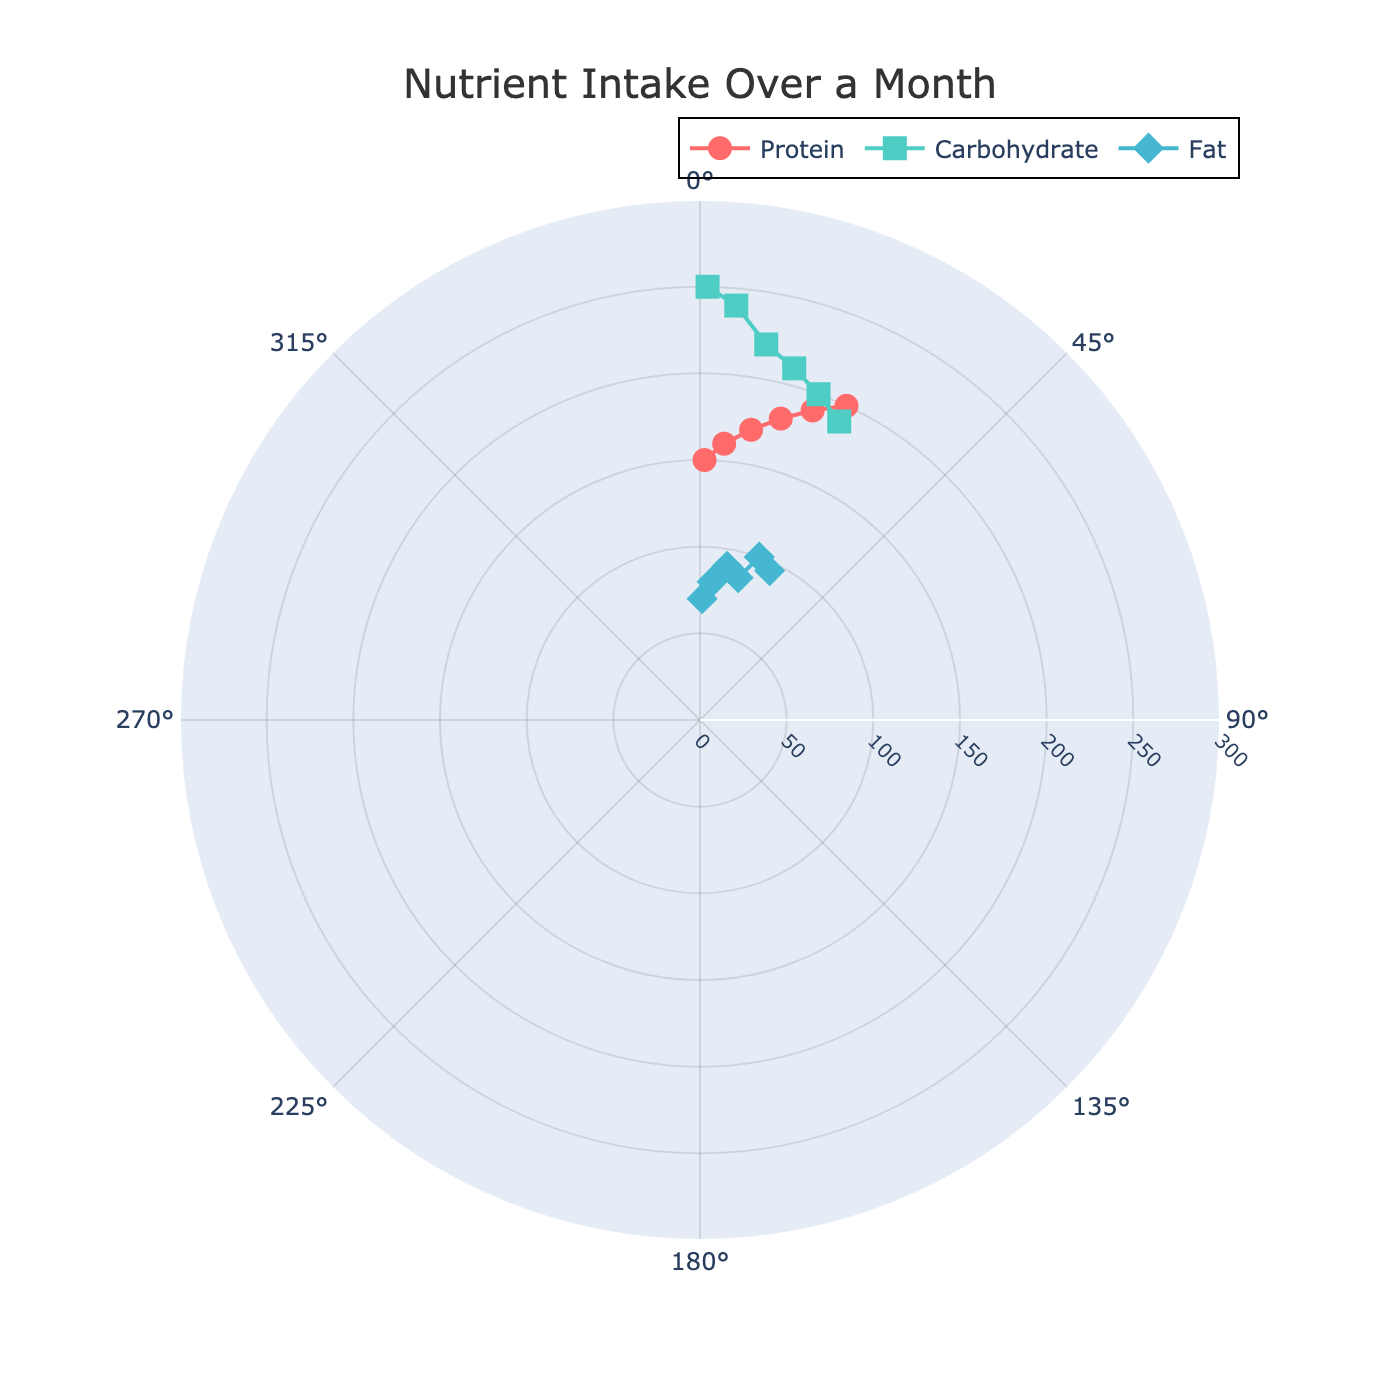How many data points are represented for each nutrient? The plot shows markers for each nutrient on multiple days. For each nutrient, there are data points on days 1, 5, 10, 15, 20, and 25. So, each nutrient has 6 data points.
Answer: 6 What days were protein intake measurements taken? Observing the plot, protein intake data points are found on days 1, 5, 10, 15, 20, and 25, as represented by the circular markers.
Answer: 1, 5, 10, 15, 20, 25 What is the intake of fat on day 10? The plot shows a diamond marker for fat data. Looking at the diamond marker on day 10, the fat intake is at 90g.
Answer: 90g Which nutrient had the highest intake on day 25? On day 25, the maximum value among nutrients is represented. Protein intake is 200g, carbohydrate intake is 190g, and fat intake is 95g. Therefore, the highest nutrient intake on day 25 is protein.
Answer: Protein How does the intake of carbohydrates on day 1 compare to day 15? On day 1, the carbohydrate intake is 250g, and on day 15, it is 210g. Comparing these values, day 1 has a higher carbohydrate intake than day 15.
Answer: Day 1 is higher What is the average fat intake across all days? Fat intakes are: 70g, 80g, 90g, 85g, 100g, and 95g. Summing these gives 520g. There are 6 days, so the average is 520g/6.
Answer: 86.67g On which day was protein intake closest to fat intake? Checking the plot for protein and fat at each day, on day 20, protein intake is 190g and fat intake is 100g; this difference (90g) is the closest when comparing other days' differences.
Answer: Day 20 What trend do you notice for protein intake over the month? As seen on the plot, the protein intake increases steadily from day 1 to day 25, indicating a consistent upward trend over the month.
Answer: Steady increase 